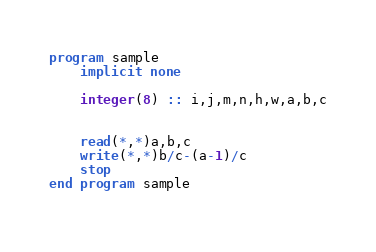Convert code to text. <code><loc_0><loc_0><loc_500><loc_500><_FORTRAN_>program sample
    implicit none
   
    integer(8) :: i,j,m,n,h,w,a,b,c
    
  
    read(*,*)a,b,c
    write(*,*)b/c-(a-1)/c
    stop
end program sample
  

</code> 